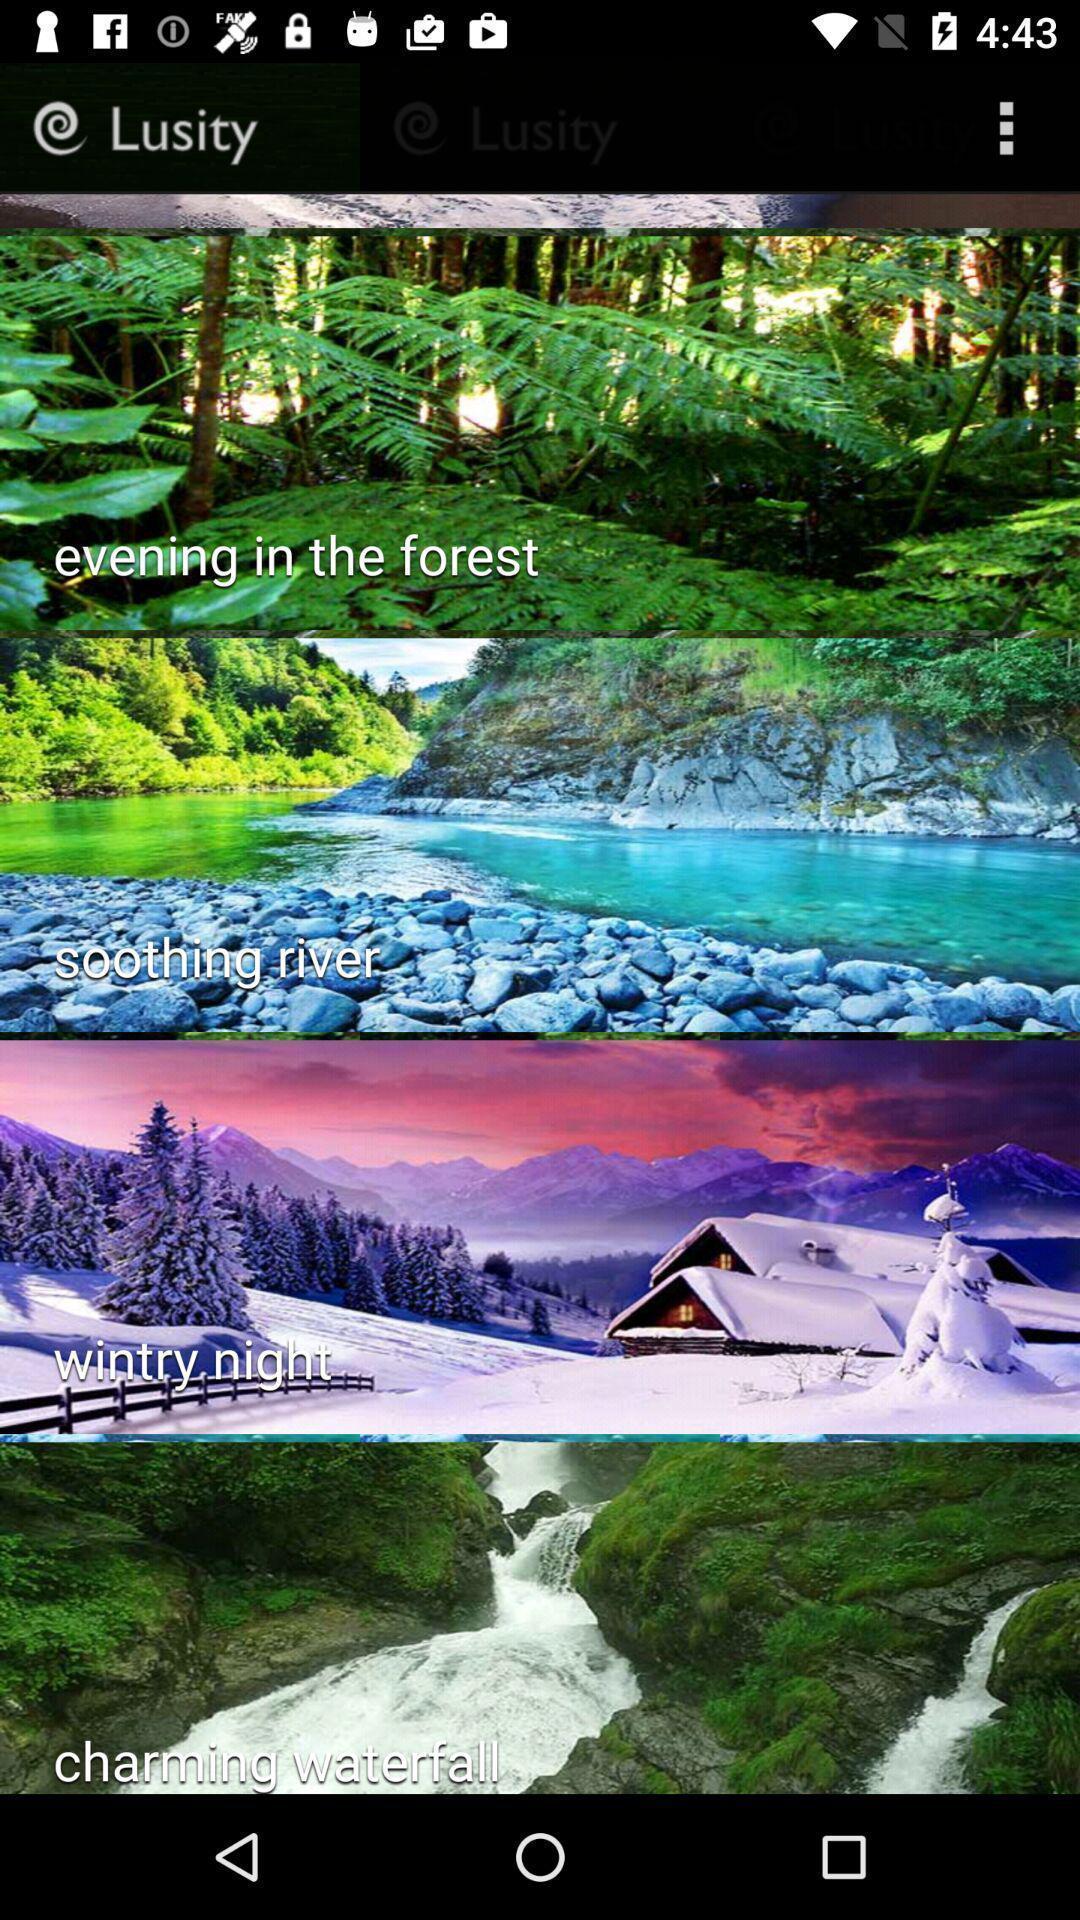Provide a detailed account of this screenshot. Screen page displaying various images. 